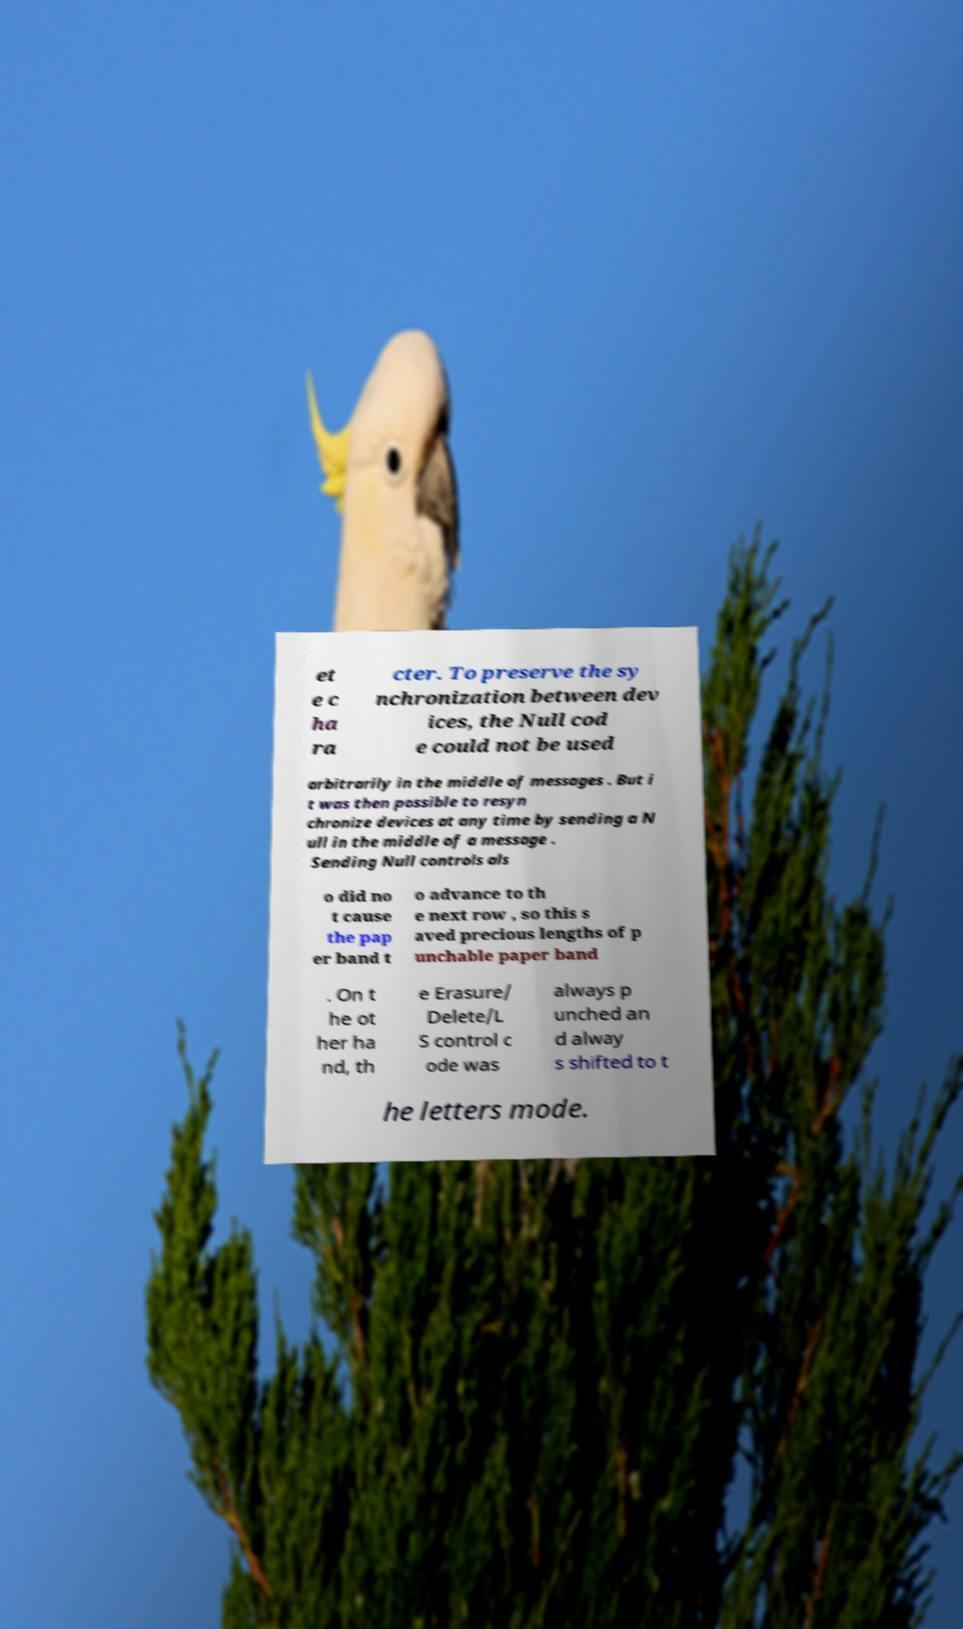Please identify and transcribe the text found in this image. et e c ha ra cter. To preserve the sy nchronization between dev ices, the Null cod e could not be used arbitrarily in the middle of messages . But i t was then possible to resyn chronize devices at any time by sending a N ull in the middle of a message . Sending Null controls als o did no t cause the pap er band t o advance to th e next row , so this s aved precious lengths of p unchable paper band . On t he ot her ha nd, th e Erasure/ Delete/L S control c ode was always p unched an d alway s shifted to t he letters mode. 